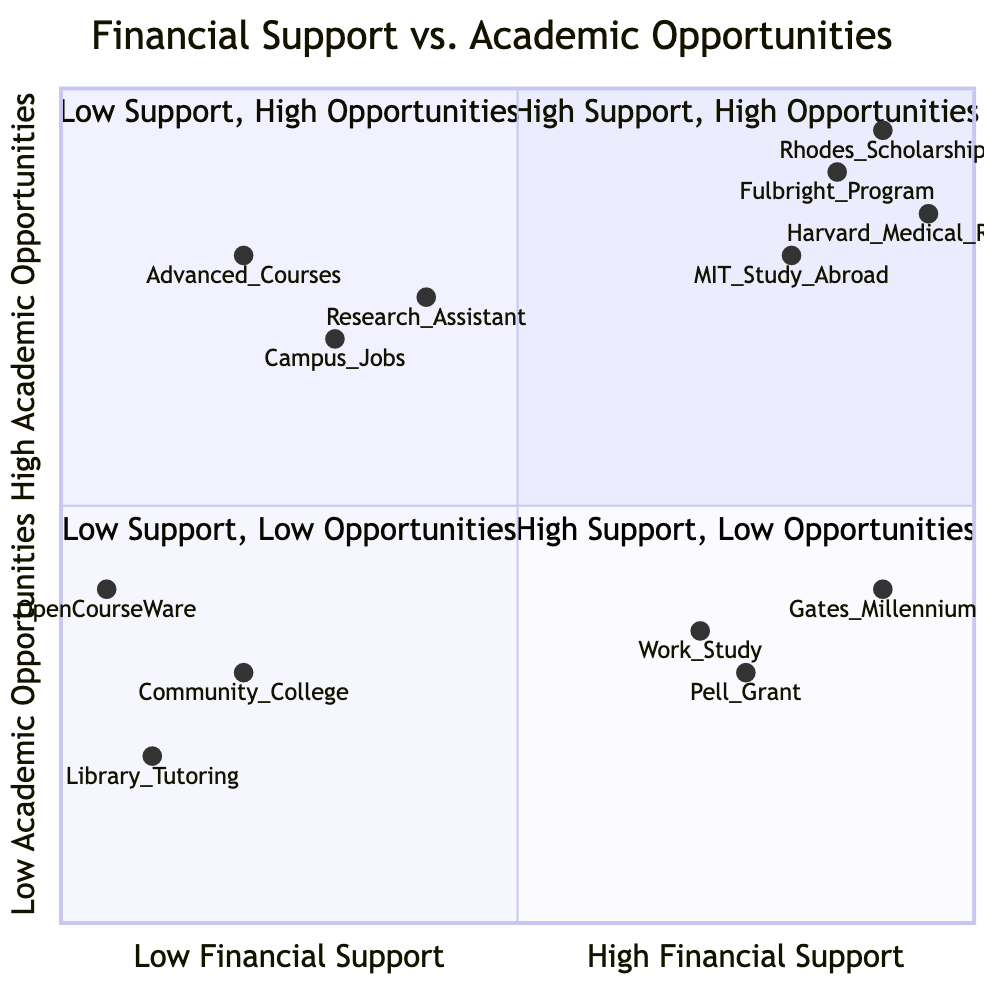What elements fall in the High Financial Support, High Academic Opportunities quadrant? The High Financial Support, High Academic Opportunities quadrant includes four elements: Rhodes Scholarship, Fulbright Program, Harvard Medical Research Center Internship, and MIT Study Abroad Program.
Answer: Rhodes Scholarship, Fulbright Program, Harvard Medical Research Center Internship, MIT Study Abroad Program How many elements are represented in the Low Support, High Opportunities quadrant? The Low Support, High Opportunities quadrant contains three elements: Part-time Campus Jobs, Research Assistant Positions, and Advanced Undergraduate Courses, totaling to three.
Answer: 3 Which element represents a research project in the diagram? The diagram shows that the Harvard Medical Research Center Internship is explicitly categorized as a research project among the listed elements.
Answer: Harvard Medical Research Center Internship What type of support does the Gates Millennium Scholars Program offer? The Gates Millennium Scholars Program is categorized as a scholarship, which indicates the type of financial support it provides.
Answer: scholarship In which quadrant would you find online OpenCourseWare Tutorials? Online OpenCourseWare Tutorials are located in the Low Financial Support, Low Academic Opportunities quadrant, as specified in the diagram's categorization.
Answer: Low Financial Support, Low Academic Opportunities quadrant What is the main difference between the High Financial Support, Low Academic Opportunities quadrant and the Low Financial Support, High Academic Opportunities quadrant? The main difference is that the first quadrant (High Financial Support, Low Academic Opportunities) has access to financial resources but limited academic opportunities, while the second quadrant (Low Financial Support, High Academic Opportunities) has limited financial support but greater academic opportunities available.
Answer: Financial resources vs. academic opportunities Which element has the lowest placement in academic opportunities? Among all the elements, the Online OpenCourseWare Tutorials have the lowest placement in academic opportunities, as indicated by their coordinates in the quadrants diagram.
Answer: Online OpenCourseWare Tutorials What does a high value on the x-axis indicate? A high value on the x-axis signifies a high level of financial support, suggesting that the elements are associated with significant financial aid resources.
Answer: High financial support How many total quadrants are presented in the diagram? The diagram presents four distinct quadrants, each representing a different combination of financial support and academic opportunities.
Answer: 4 